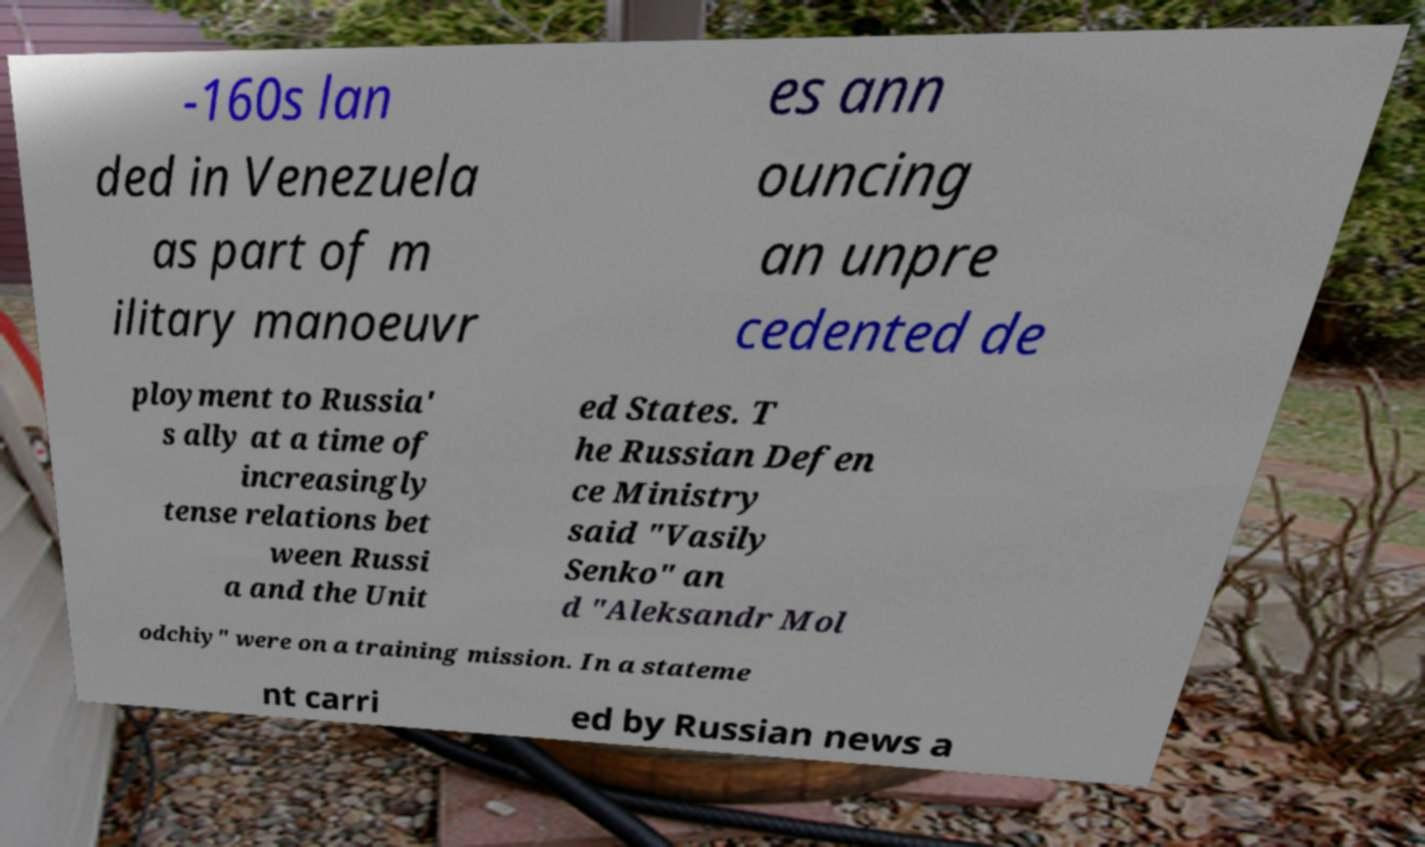Please identify and transcribe the text found in this image. -160s lan ded in Venezuela as part of m ilitary manoeuvr es ann ouncing an unpre cedented de ployment to Russia' s ally at a time of increasingly tense relations bet ween Russi a and the Unit ed States. T he Russian Defen ce Ministry said "Vasily Senko" an d "Aleksandr Mol odchiy" were on a training mission. In a stateme nt carri ed by Russian news a 